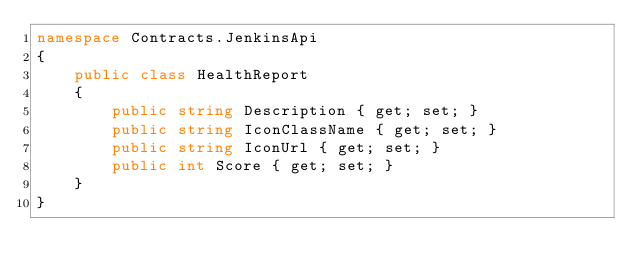Convert code to text. <code><loc_0><loc_0><loc_500><loc_500><_C#_>namespace Contracts.JenkinsApi
{
    public class HealthReport
    {
        public string Description { get; set; }
        public string IconClassName { get; set; }
        public string IconUrl { get; set; }
        public int Score { get; set; }
    }
}</code> 